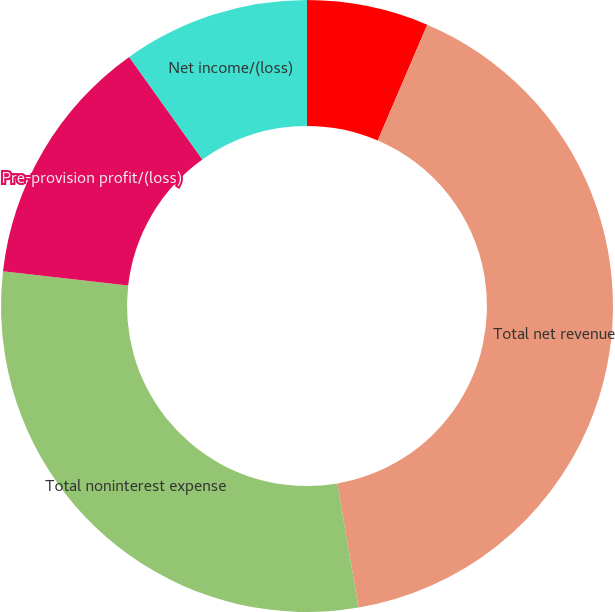Convert chart to OTSL. <chart><loc_0><loc_0><loc_500><loc_500><pie_chart><fcel>(in millions except ratios)<fcel>Total net revenue<fcel>Total noninterest expense<fcel>Pre-provision profit/(loss)<fcel>Net income/(loss)<nl><fcel>6.43%<fcel>40.88%<fcel>29.51%<fcel>13.32%<fcel>9.87%<nl></chart> 